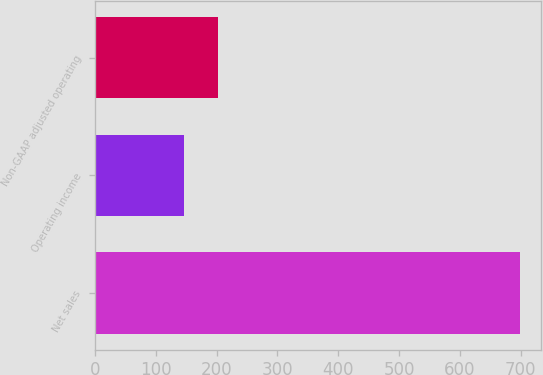Convert chart. <chart><loc_0><loc_0><loc_500><loc_500><bar_chart><fcel>Net sales<fcel>Operating income<fcel>Non-GAAP adjusted operating<nl><fcel>699<fcel>147<fcel>202.2<nl></chart> 